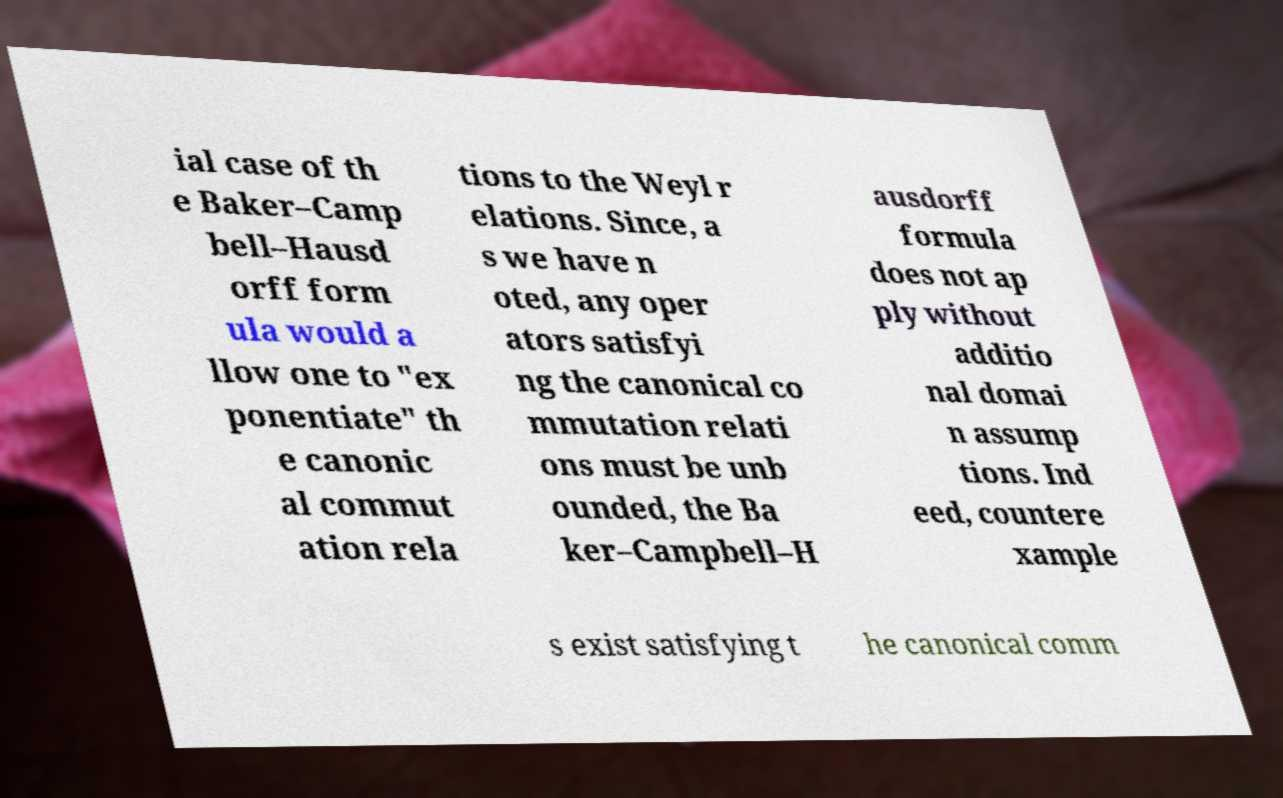Could you extract and type out the text from this image? ial case of th e Baker–Camp bell–Hausd orff form ula would a llow one to "ex ponentiate" th e canonic al commut ation rela tions to the Weyl r elations. Since, a s we have n oted, any oper ators satisfyi ng the canonical co mmutation relati ons must be unb ounded, the Ba ker–Campbell–H ausdorff formula does not ap ply without additio nal domai n assump tions. Ind eed, countere xample s exist satisfying t he canonical comm 